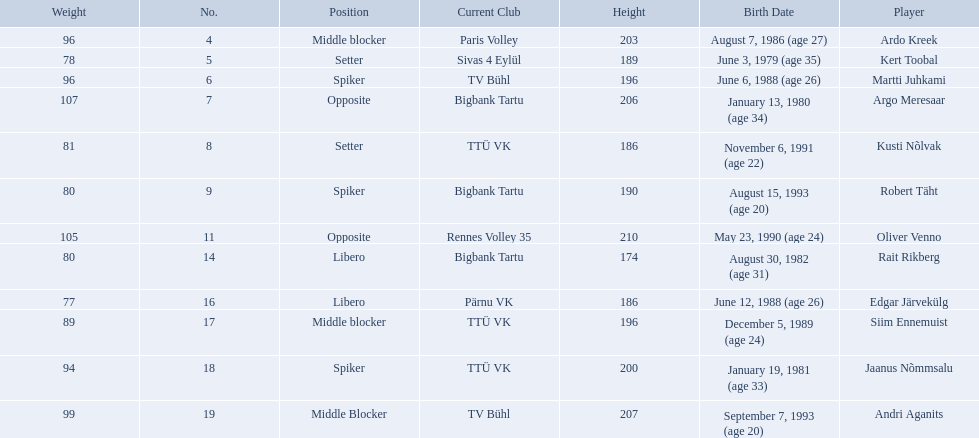Who are all of the players? Ardo Kreek, Kert Toobal, Martti Juhkami, Argo Meresaar, Kusti Nõlvak, Robert Täht, Oliver Venno, Rait Rikberg, Edgar Järvekülg, Siim Ennemuist, Jaanus Nõmmsalu, Andri Aganits. How tall are they? 203, 189, 196, 206, 186, 190, 210, 174, 186, 196, 200, 207. And which player is tallest? Oliver Venno. 